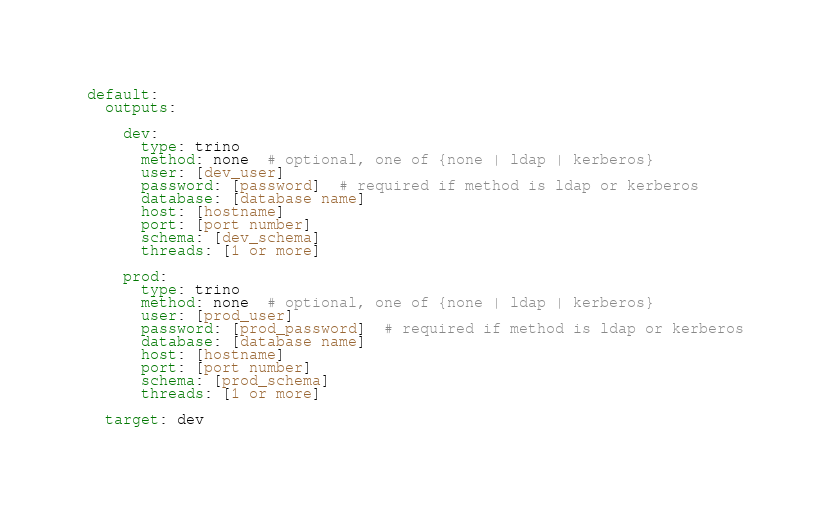Convert code to text. <code><loc_0><loc_0><loc_500><loc_500><_YAML_>default:
  outputs:

    dev:
      type: trino
      method: none  # optional, one of {none | ldap | kerberos}
      user: [dev_user]
      password: [password]  # required if method is ldap or kerberos
      database: [database name]
      host: [hostname]
      port: [port number]
      schema: [dev_schema]
      threads: [1 or more]

    prod:
      type: trino
      method: none  # optional, one of {none | ldap | kerberos}
      user: [prod_user]
      password: [prod_password]  # required if method is ldap or kerberos
      database: [database name]
      host: [hostname]
      port: [port number]
      schema: [prod_schema]
      threads: [1 or more]
  
  target: dev
</code> 